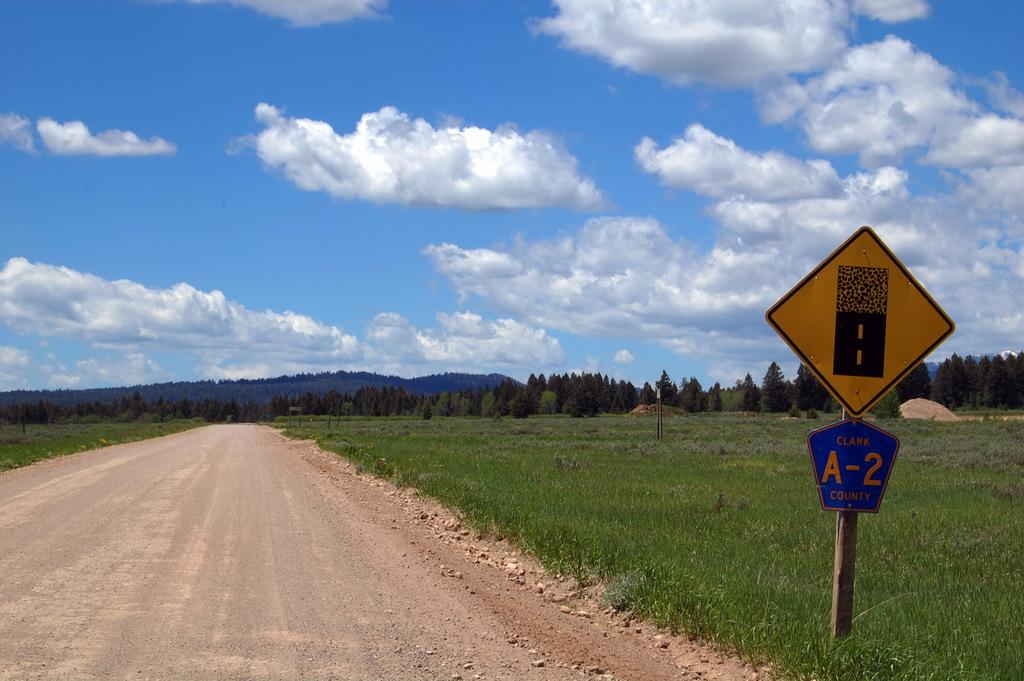<image>
Share a concise interpretation of the image provided. Blue and yellow sign with one saying A-2 on it. 